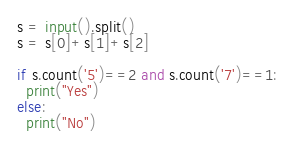Convert code to text. <code><loc_0><loc_0><loc_500><loc_500><_Python_>s = input().split()
s = s[0]+s[1]+s[2]

if s.count('5')==2 and s.count('7')==1:
  print("Yes")
else:
  print("No")
</code> 